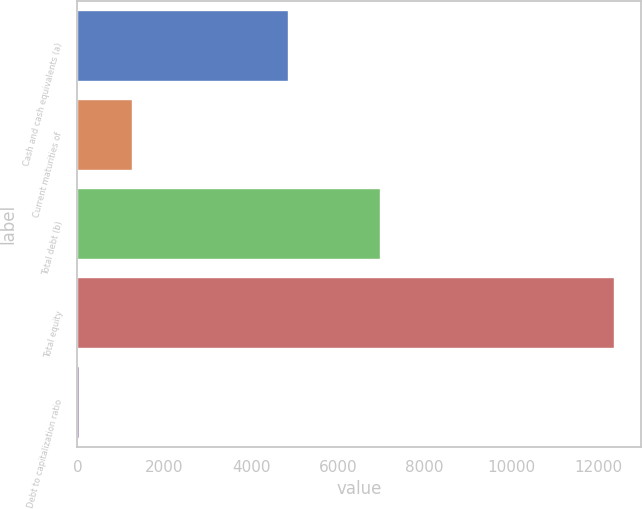Convert chart. <chart><loc_0><loc_0><loc_500><loc_500><bar_chart><fcel>Cash and cash equivalents (a)<fcel>Current maturities of<fcel>Total debt (b)<fcel>Total equity<fcel>Debt to capitalization ratio<nl><fcel>4847<fcel>1267.89<fcel>6977<fcel>12354<fcel>36.1<nl></chart> 